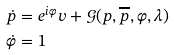Convert formula to latex. <formula><loc_0><loc_0><loc_500><loc_500>\dot { p } & = e ^ { i \varphi } v + { \mathcal { G } } ( p , \overline { p } , \varphi , \lambda ) \\ \dot { \varphi } & = 1</formula> 